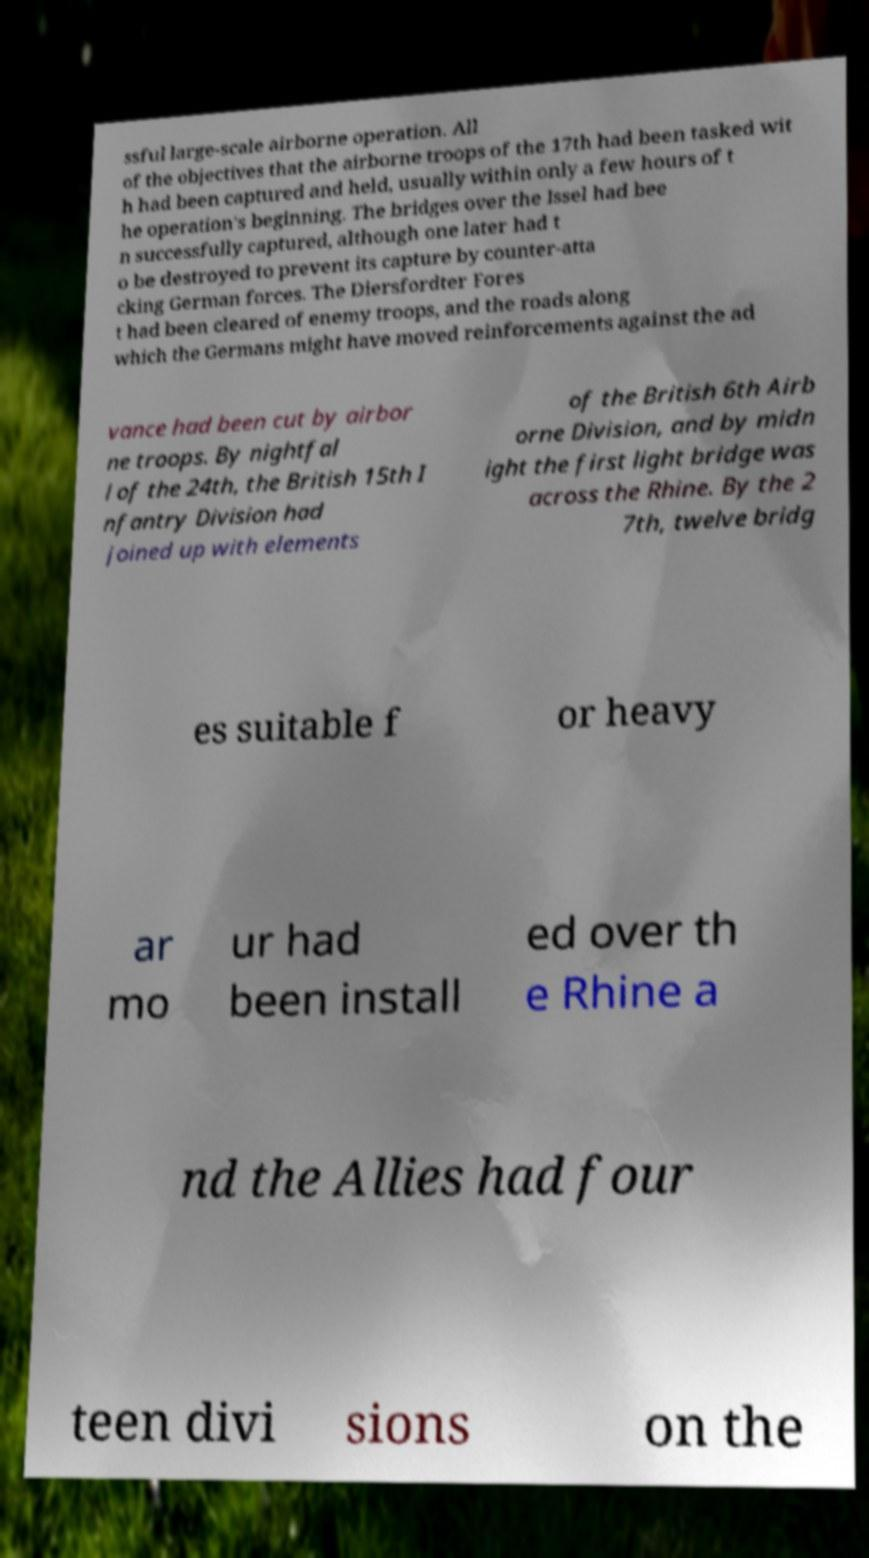For documentation purposes, I need the text within this image transcribed. Could you provide that? ssful large-scale airborne operation. All of the objectives that the airborne troops of the 17th had been tasked wit h had been captured and held, usually within only a few hours of t he operation's beginning. The bridges over the Issel had bee n successfully captured, although one later had t o be destroyed to prevent its capture by counter-atta cking German forces. The Diersfordter Fores t had been cleared of enemy troops, and the roads along which the Germans might have moved reinforcements against the ad vance had been cut by airbor ne troops. By nightfal l of the 24th, the British 15th I nfantry Division had joined up with elements of the British 6th Airb orne Division, and by midn ight the first light bridge was across the Rhine. By the 2 7th, twelve bridg es suitable f or heavy ar mo ur had been install ed over th e Rhine a nd the Allies had four teen divi sions on the 